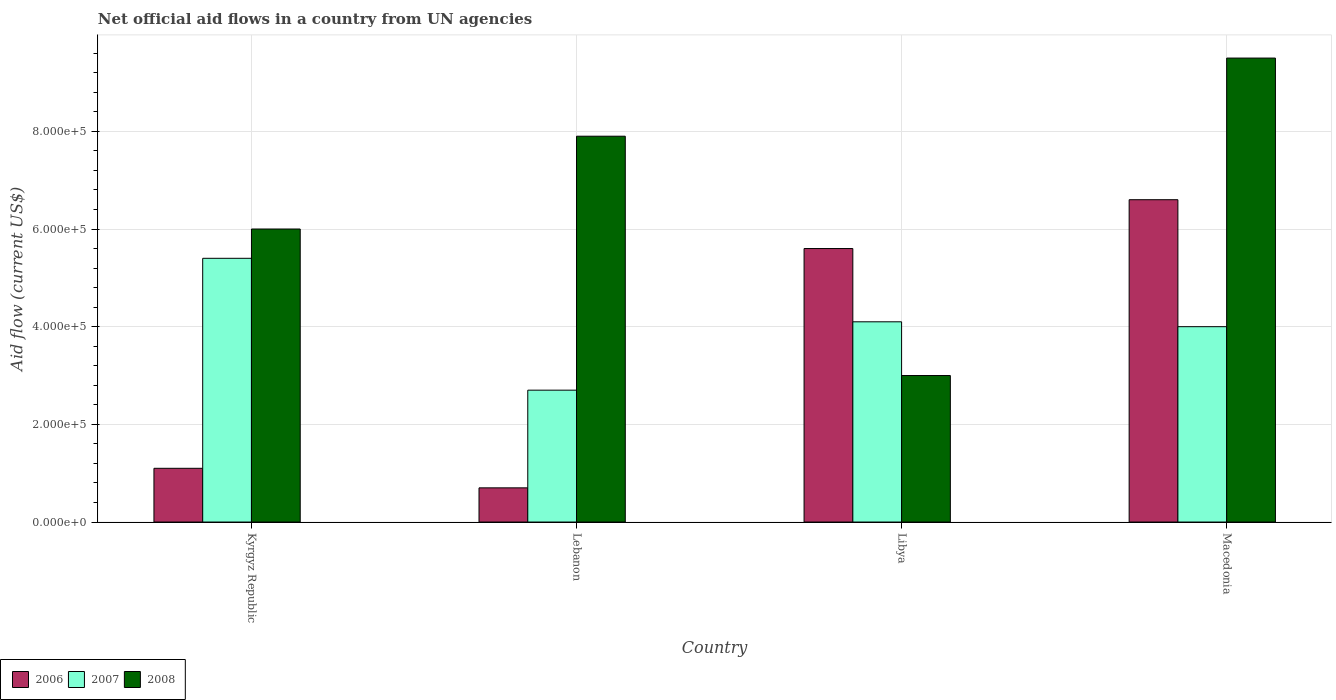How many different coloured bars are there?
Ensure brevity in your answer.  3. Are the number of bars per tick equal to the number of legend labels?
Offer a very short reply. Yes. How many bars are there on the 1st tick from the left?
Offer a very short reply. 3. How many bars are there on the 1st tick from the right?
Your response must be concise. 3. What is the label of the 2nd group of bars from the left?
Make the answer very short. Lebanon. What is the net official aid flow in 2008 in Macedonia?
Provide a short and direct response. 9.50e+05. Across all countries, what is the minimum net official aid flow in 2007?
Provide a short and direct response. 2.70e+05. In which country was the net official aid flow in 2008 maximum?
Offer a terse response. Macedonia. In which country was the net official aid flow in 2006 minimum?
Make the answer very short. Lebanon. What is the total net official aid flow in 2007 in the graph?
Make the answer very short. 1.62e+06. What is the difference between the net official aid flow in 2006 in Kyrgyz Republic and that in Lebanon?
Keep it short and to the point. 4.00e+04. What is the difference between the net official aid flow in 2008 in Libya and the net official aid flow in 2006 in Macedonia?
Offer a very short reply. -3.60e+05. What is the difference between the net official aid flow of/in 2008 and net official aid flow of/in 2006 in Lebanon?
Offer a very short reply. 7.20e+05. In how many countries, is the net official aid flow in 2007 greater than 360000 US$?
Keep it short and to the point. 3. What is the ratio of the net official aid flow in 2008 in Kyrgyz Republic to that in Lebanon?
Give a very brief answer. 0.76. What is the difference between the highest and the lowest net official aid flow in 2006?
Keep it short and to the point. 5.90e+05. In how many countries, is the net official aid flow in 2008 greater than the average net official aid flow in 2008 taken over all countries?
Make the answer very short. 2. What does the 3rd bar from the left in Macedonia represents?
Make the answer very short. 2008. How many bars are there?
Keep it short and to the point. 12. Are all the bars in the graph horizontal?
Offer a terse response. No. How are the legend labels stacked?
Provide a succinct answer. Horizontal. What is the title of the graph?
Give a very brief answer. Net official aid flows in a country from UN agencies. What is the label or title of the Y-axis?
Provide a short and direct response. Aid flow (current US$). What is the Aid flow (current US$) of 2006 in Kyrgyz Republic?
Your answer should be compact. 1.10e+05. What is the Aid flow (current US$) of 2007 in Kyrgyz Republic?
Offer a terse response. 5.40e+05. What is the Aid flow (current US$) of 2006 in Lebanon?
Your answer should be very brief. 7.00e+04. What is the Aid flow (current US$) in 2007 in Lebanon?
Offer a terse response. 2.70e+05. What is the Aid flow (current US$) in 2008 in Lebanon?
Make the answer very short. 7.90e+05. What is the Aid flow (current US$) in 2006 in Libya?
Your response must be concise. 5.60e+05. What is the Aid flow (current US$) in 2007 in Libya?
Keep it short and to the point. 4.10e+05. What is the Aid flow (current US$) in 2006 in Macedonia?
Provide a succinct answer. 6.60e+05. What is the Aid flow (current US$) of 2008 in Macedonia?
Offer a very short reply. 9.50e+05. Across all countries, what is the maximum Aid flow (current US$) of 2006?
Your answer should be compact. 6.60e+05. Across all countries, what is the maximum Aid flow (current US$) of 2007?
Your response must be concise. 5.40e+05. Across all countries, what is the maximum Aid flow (current US$) in 2008?
Provide a succinct answer. 9.50e+05. Across all countries, what is the minimum Aid flow (current US$) in 2007?
Your answer should be very brief. 2.70e+05. What is the total Aid flow (current US$) of 2006 in the graph?
Give a very brief answer. 1.40e+06. What is the total Aid flow (current US$) of 2007 in the graph?
Offer a very short reply. 1.62e+06. What is the total Aid flow (current US$) in 2008 in the graph?
Offer a terse response. 2.64e+06. What is the difference between the Aid flow (current US$) of 2006 in Kyrgyz Republic and that in Lebanon?
Your response must be concise. 4.00e+04. What is the difference between the Aid flow (current US$) of 2007 in Kyrgyz Republic and that in Lebanon?
Your answer should be compact. 2.70e+05. What is the difference between the Aid flow (current US$) in 2006 in Kyrgyz Republic and that in Libya?
Provide a short and direct response. -4.50e+05. What is the difference between the Aid flow (current US$) of 2006 in Kyrgyz Republic and that in Macedonia?
Offer a very short reply. -5.50e+05. What is the difference between the Aid flow (current US$) in 2007 in Kyrgyz Republic and that in Macedonia?
Give a very brief answer. 1.40e+05. What is the difference between the Aid flow (current US$) in 2008 in Kyrgyz Republic and that in Macedonia?
Your answer should be very brief. -3.50e+05. What is the difference between the Aid flow (current US$) of 2006 in Lebanon and that in Libya?
Keep it short and to the point. -4.90e+05. What is the difference between the Aid flow (current US$) in 2007 in Lebanon and that in Libya?
Offer a terse response. -1.40e+05. What is the difference between the Aid flow (current US$) of 2008 in Lebanon and that in Libya?
Provide a short and direct response. 4.90e+05. What is the difference between the Aid flow (current US$) in 2006 in Lebanon and that in Macedonia?
Your answer should be very brief. -5.90e+05. What is the difference between the Aid flow (current US$) in 2007 in Lebanon and that in Macedonia?
Give a very brief answer. -1.30e+05. What is the difference between the Aid flow (current US$) in 2008 in Lebanon and that in Macedonia?
Your response must be concise. -1.60e+05. What is the difference between the Aid flow (current US$) of 2006 in Libya and that in Macedonia?
Make the answer very short. -1.00e+05. What is the difference between the Aid flow (current US$) of 2007 in Libya and that in Macedonia?
Provide a short and direct response. 10000. What is the difference between the Aid flow (current US$) of 2008 in Libya and that in Macedonia?
Ensure brevity in your answer.  -6.50e+05. What is the difference between the Aid flow (current US$) in 2006 in Kyrgyz Republic and the Aid flow (current US$) in 2008 in Lebanon?
Offer a terse response. -6.80e+05. What is the difference between the Aid flow (current US$) in 2007 in Kyrgyz Republic and the Aid flow (current US$) in 2008 in Lebanon?
Your answer should be compact. -2.50e+05. What is the difference between the Aid flow (current US$) of 2006 in Kyrgyz Republic and the Aid flow (current US$) of 2007 in Libya?
Keep it short and to the point. -3.00e+05. What is the difference between the Aid flow (current US$) of 2006 in Kyrgyz Republic and the Aid flow (current US$) of 2008 in Libya?
Provide a succinct answer. -1.90e+05. What is the difference between the Aid flow (current US$) in 2007 in Kyrgyz Republic and the Aid flow (current US$) in 2008 in Libya?
Your response must be concise. 2.40e+05. What is the difference between the Aid flow (current US$) in 2006 in Kyrgyz Republic and the Aid flow (current US$) in 2007 in Macedonia?
Ensure brevity in your answer.  -2.90e+05. What is the difference between the Aid flow (current US$) of 2006 in Kyrgyz Republic and the Aid flow (current US$) of 2008 in Macedonia?
Your answer should be compact. -8.40e+05. What is the difference between the Aid flow (current US$) in 2007 in Kyrgyz Republic and the Aid flow (current US$) in 2008 in Macedonia?
Give a very brief answer. -4.10e+05. What is the difference between the Aid flow (current US$) of 2006 in Lebanon and the Aid flow (current US$) of 2007 in Libya?
Provide a succinct answer. -3.40e+05. What is the difference between the Aid flow (current US$) of 2006 in Lebanon and the Aid flow (current US$) of 2008 in Libya?
Your answer should be compact. -2.30e+05. What is the difference between the Aid flow (current US$) in 2007 in Lebanon and the Aid flow (current US$) in 2008 in Libya?
Your answer should be compact. -3.00e+04. What is the difference between the Aid flow (current US$) in 2006 in Lebanon and the Aid flow (current US$) in 2007 in Macedonia?
Provide a short and direct response. -3.30e+05. What is the difference between the Aid flow (current US$) in 2006 in Lebanon and the Aid flow (current US$) in 2008 in Macedonia?
Your response must be concise. -8.80e+05. What is the difference between the Aid flow (current US$) in 2007 in Lebanon and the Aid flow (current US$) in 2008 in Macedonia?
Give a very brief answer. -6.80e+05. What is the difference between the Aid flow (current US$) in 2006 in Libya and the Aid flow (current US$) in 2007 in Macedonia?
Keep it short and to the point. 1.60e+05. What is the difference between the Aid flow (current US$) in 2006 in Libya and the Aid flow (current US$) in 2008 in Macedonia?
Provide a short and direct response. -3.90e+05. What is the difference between the Aid flow (current US$) of 2007 in Libya and the Aid flow (current US$) of 2008 in Macedonia?
Provide a succinct answer. -5.40e+05. What is the average Aid flow (current US$) of 2007 per country?
Offer a very short reply. 4.05e+05. What is the average Aid flow (current US$) of 2008 per country?
Provide a short and direct response. 6.60e+05. What is the difference between the Aid flow (current US$) of 2006 and Aid flow (current US$) of 2007 in Kyrgyz Republic?
Make the answer very short. -4.30e+05. What is the difference between the Aid flow (current US$) in 2006 and Aid flow (current US$) in 2008 in Kyrgyz Republic?
Your response must be concise. -4.90e+05. What is the difference between the Aid flow (current US$) in 2006 and Aid flow (current US$) in 2007 in Lebanon?
Your response must be concise. -2.00e+05. What is the difference between the Aid flow (current US$) of 2006 and Aid flow (current US$) of 2008 in Lebanon?
Provide a short and direct response. -7.20e+05. What is the difference between the Aid flow (current US$) of 2007 and Aid flow (current US$) of 2008 in Lebanon?
Your answer should be compact. -5.20e+05. What is the difference between the Aid flow (current US$) of 2006 and Aid flow (current US$) of 2007 in Macedonia?
Offer a very short reply. 2.60e+05. What is the difference between the Aid flow (current US$) of 2007 and Aid flow (current US$) of 2008 in Macedonia?
Offer a very short reply. -5.50e+05. What is the ratio of the Aid flow (current US$) in 2006 in Kyrgyz Republic to that in Lebanon?
Provide a succinct answer. 1.57. What is the ratio of the Aid flow (current US$) of 2008 in Kyrgyz Republic to that in Lebanon?
Provide a succinct answer. 0.76. What is the ratio of the Aid flow (current US$) of 2006 in Kyrgyz Republic to that in Libya?
Offer a very short reply. 0.2. What is the ratio of the Aid flow (current US$) in 2007 in Kyrgyz Republic to that in Libya?
Make the answer very short. 1.32. What is the ratio of the Aid flow (current US$) of 2008 in Kyrgyz Republic to that in Libya?
Give a very brief answer. 2. What is the ratio of the Aid flow (current US$) of 2007 in Kyrgyz Republic to that in Macedonia?
Provide a short and direct response. 1.35. What is the ratio of the Aid flow (current US$) in 2008 in Kyrgyz Republic to that in Macedonia?
Give a very brief answer. 0.63. What is the ratio of the Aid flow (current US$) in 2007 in Lebanon to that in Libya?
Offer a terse response. 0.66. What is the ratio of the Aid flow (current US$) of 2008 in Lebanon to that in Libya?
Your answer should be very brief. 2.63. What is the ratio of the Aid flow (current US$) in 2006 in Lebanon to that in Macedonia?
Make the answer very short. 0.11. What is the ratio of the Aid flow (current US$) of 2007 in Lebanon to that in Macedonia?
Provide a succinct answer. 0.68. What is the ratio of the Aid flow (current US$) of 2008 in Lebanon to that in Macedonia?
Provide a succinct answer. 0.83. What is the ratio of the Aid flow (current US$) of 2006 in Libya to that in Macedonia?
Your answer should be very brief. 0.85. What is the ratio of the Aid flow (current US$) in 2007 in Libya to that in Macedonia?
Offer a very short reply. 1.02. What is the ratio of the Aid flow (current US$) in 2008 in Libya to that in Macedonia?
Your answer should be compact. 0.32. What is the difference between the highest and the lowest Aid flow (current US$) of 2006?
Your answer should be compact. 5.90e+05. What is the difference between the highest and the lowest Aid flow (current US$) in 2007?
Give a very brief answer. 2.70e+05. What is the difference between the highest and the lowest Aid flow (current US$) in 2008?
Keep it short and to the point. 6.50e+05. 